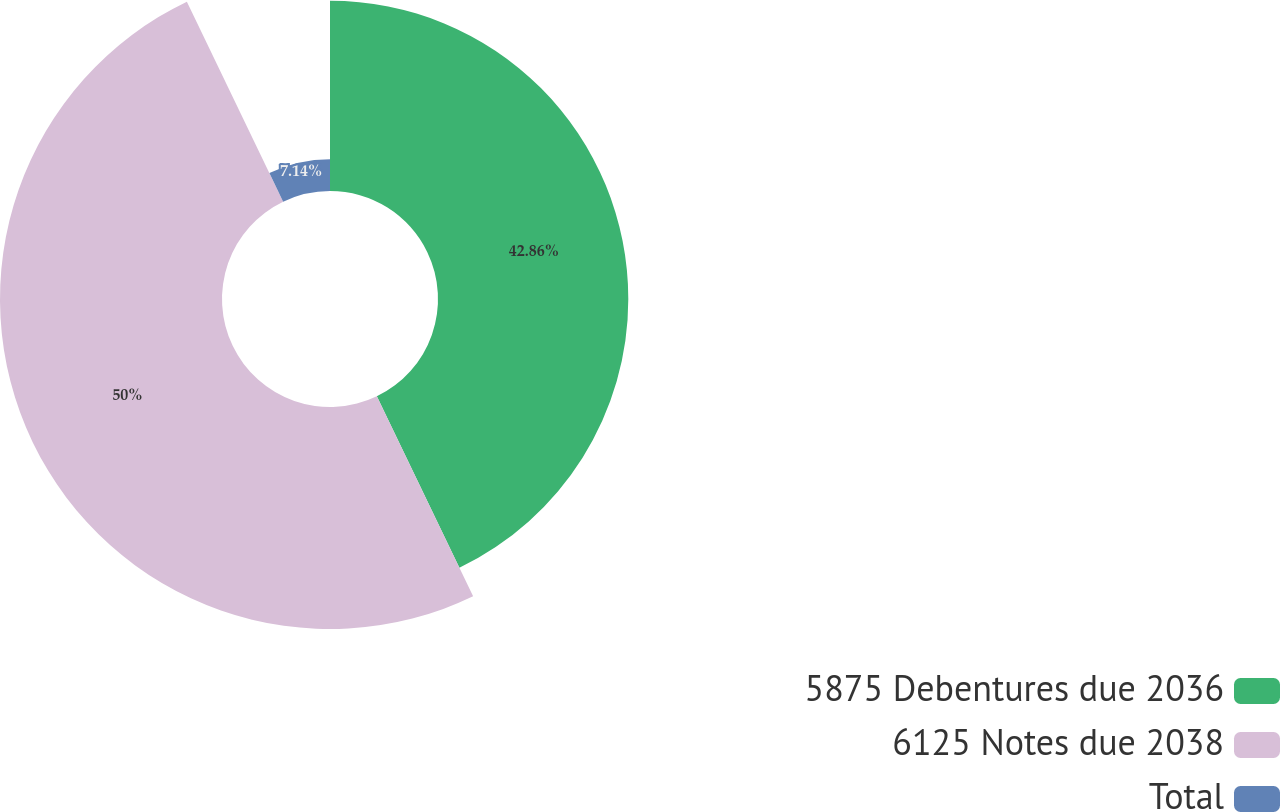Convert chart. <chart><loc_0><loc_0><loc_500><loc_500><pie_chart><fcel>5875 Debentures due 2036<fcel>6125 Notes due 2038<fcel>Total<nl><fcel>42.86%<fcel>50.0%<fcel>7.14%<nl></chart> 